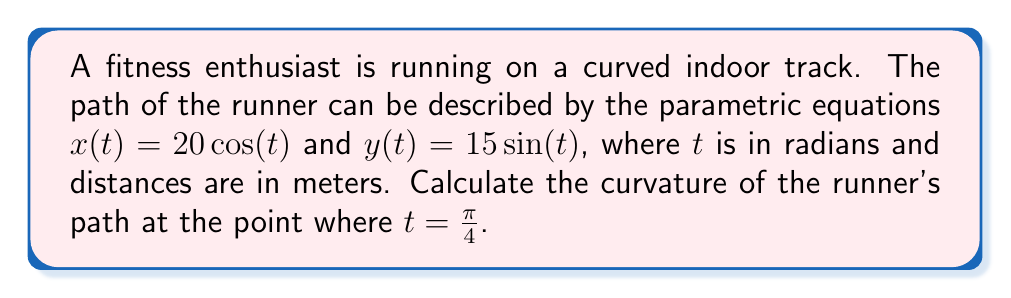Provide a solution to this math problem. To calculate the curvature of the runner's path, we'll follow these steps:

1) The curvature $\kappa$ of a parametric curve is given by:

   $$\kappa = \frac{|x'y'' - y'x''|}{(x'^2 + y'^2)^{3/2}}$$

2) First, let's calculate the first and second derivatives:
   
   $x'(t) = -20\sin(t)$
   $y'(t) = 15\cos(t)$
   $x''(t) = -20\cos(t)$
   $y''(t) = -15\sin(t)$

3) Now, let's evaluate these at $t = \frac{\pi}{4}$:
   
   $x'(\frac{\pi}{4}) = -20\sin(\frac{\pi}{4}) = -20 \cdot \frac{\sqrt{2}}{2} = -10\sqrt{2}$
   $y'(\frac{\pi}{4}) = 15\cos(\frac{\pi}{4}) = 15 \cdot \frac{\sqrt{2}}{2} = \frac{15\sqrt{2}}{2}$
   $x''(\frac{\pi}{4}) = -20\cos(\frac{\pi}{4}) = -20 \cdot \frac{\sqrt{2}}{2} = -10\sqrt{2}$
   $y''(\frac{\pi}{4}) = -15\sin(\frac{\pi}{4}) = -15 \cdot \frac{\sqrt{2}}{2} = -\frac{15\sqrt{2}}{2}$

4) Now, let's substitute these values into the curvature formula:

   $$\kappa = \frac{|(-10\sqrt{2})(-\frac{15\sqrt{2}}{2}) - (\frac{15\sqrt{2}}{2})(-10\sqrt{2})|}{((-10\sqrt{2})^2 + (\frac{15\sqrt{2}}{2})^2)^{3/2}}$$

5) Simplify the numerator:
   
   $$\kappa = \frac{|75 + 75|}{(200 + \frac{450}{4})^{3/2}} = \frac{150}{(312.5)^{3/2}}$$

6) Simplify further:
   
   $$\kappa = \frac{150}{5512.5\sqrt{312.5}} = \frac{1}{36.75\sqrt{312.5}} \approx 0.0481$$
Answer: $\frac{1}{36.75\sqrt{312.5}} \approx 0.0481 \text{ m}^{-1}$ 